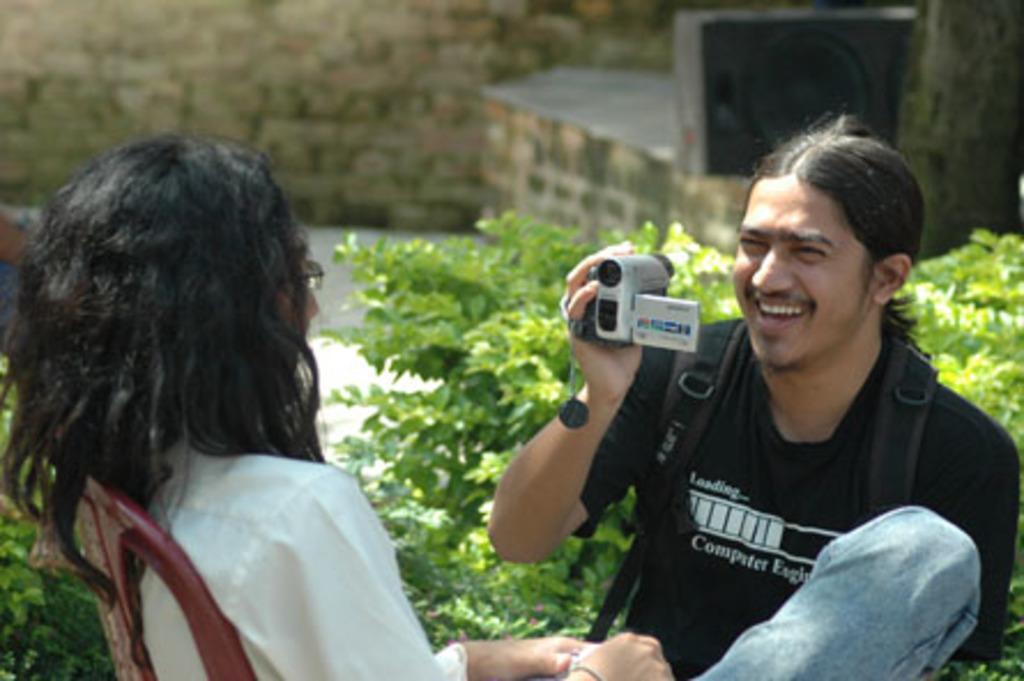Describe this image in one or two sentences. This picture shows a man and holding a camera in his hand and we see a woman seated on the chair and we see few plants 